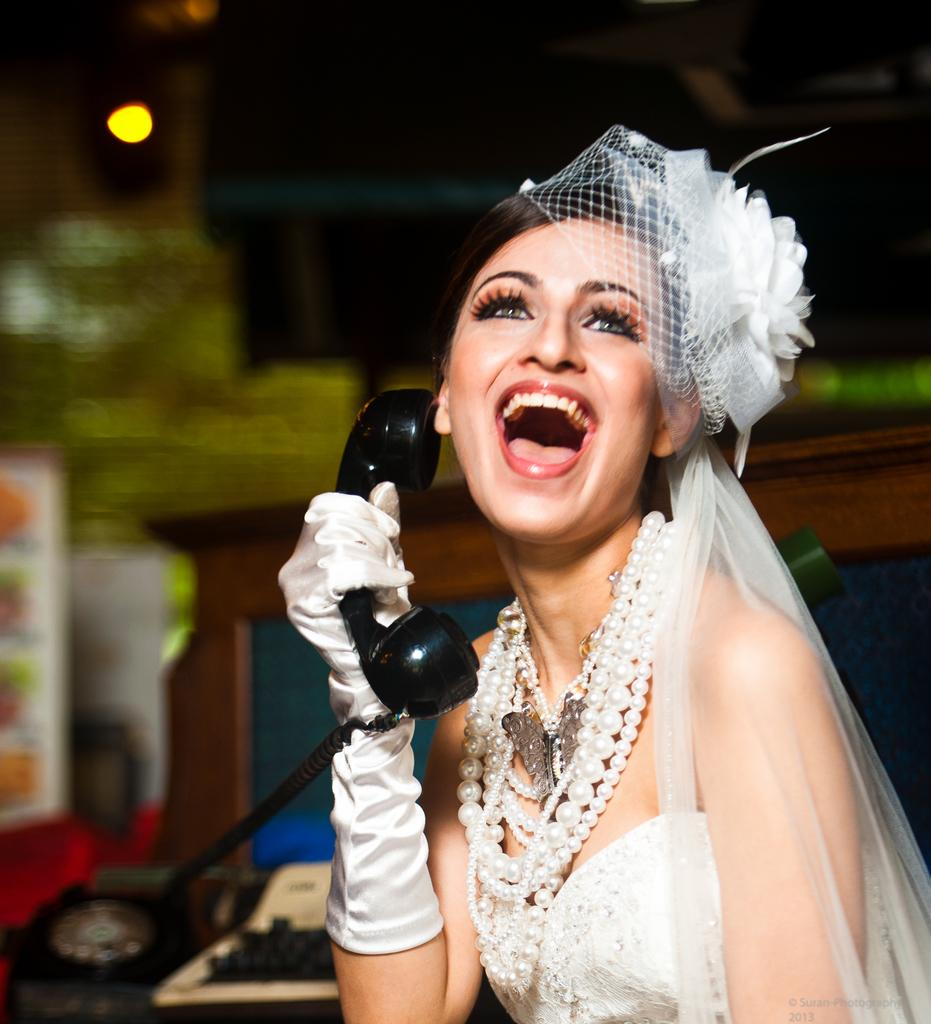What is the main subject in the foreground of the picture? There is a woman in the foreground of the picture. What is the woman wearing? The woman is wearing a white dress. What object is the woman holding? The woman is holding a telephone mic. Can you describe the background of the image? The background of the image is blurred. What type of flower is the goat holding in the image? There is no goat or flower present in the image. How does the woman show respect to her opponent in the image? The image does not show any indication of respect or lack thereof between the woman and any other person. 